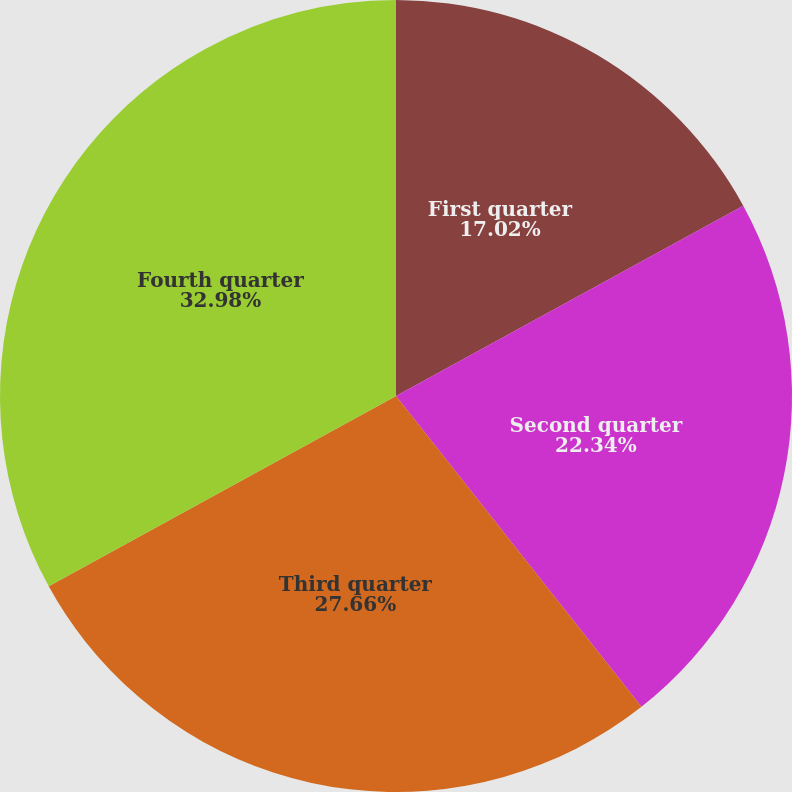Convert chart to OTSL. <chart><loc_0><loc_0><loc_500><loc_500><pie_chart><fcel>First quarter<fcel>Second quarter<fcel>Third quarter<fcel>Fourth quarter<nl><fcel>17.02%<fcel>22.34%<fcel>27.66%<fcel>32.98%<nl></chart> 